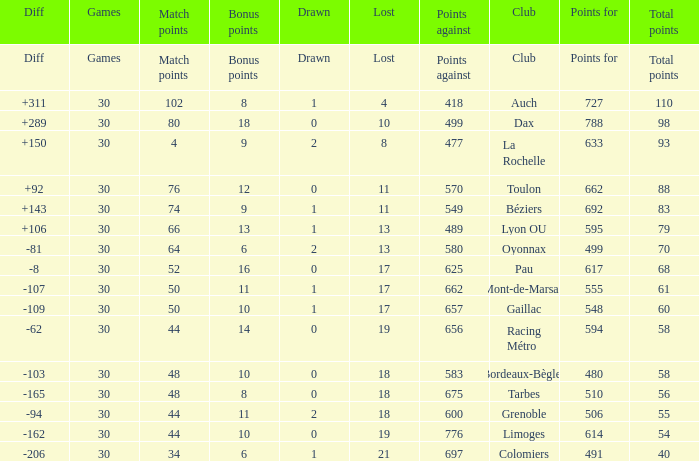What is the diff for a club that has a value of 662 for points for? 92.0. 